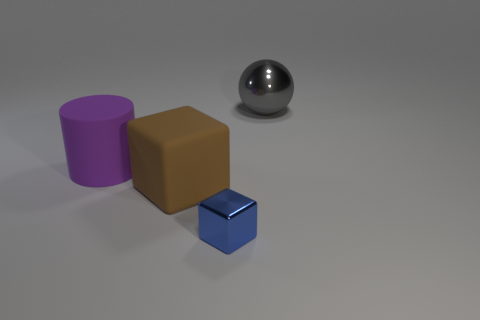What number of big things are blocks or purple rubber objects?
Your answer should be very brief. 2. Is there a gray sphere made of the same material as the purple object?
Your answer should be very brief. No. There is a big object that is right of the big block; what material is it?
Keep it short and to the point. Metal. There is a metallic thing that is behind the purple matte cylinder; is it the same color as the big thing that is left of the brown matte cube?
Keep it short and to the point. No. What color is the block that is the same size as the ball?
Keep it short and to the point. Brown. How many other things are there of the same shape as the large brown object?
Make the answer very short. 1. What is the size of the cube that is behind the small metallic thing?
Offer a very short reply. Large. How many objects are behind the metallic object in front of the large metallic ball?
Provide a succinct answer. 3. What number of other objects are there of the same size as the purple matte cylinder?
Your response must be concise. 2. Is the color of the matte cube the same as the big cylinder?
Your answer should be compact. No. 